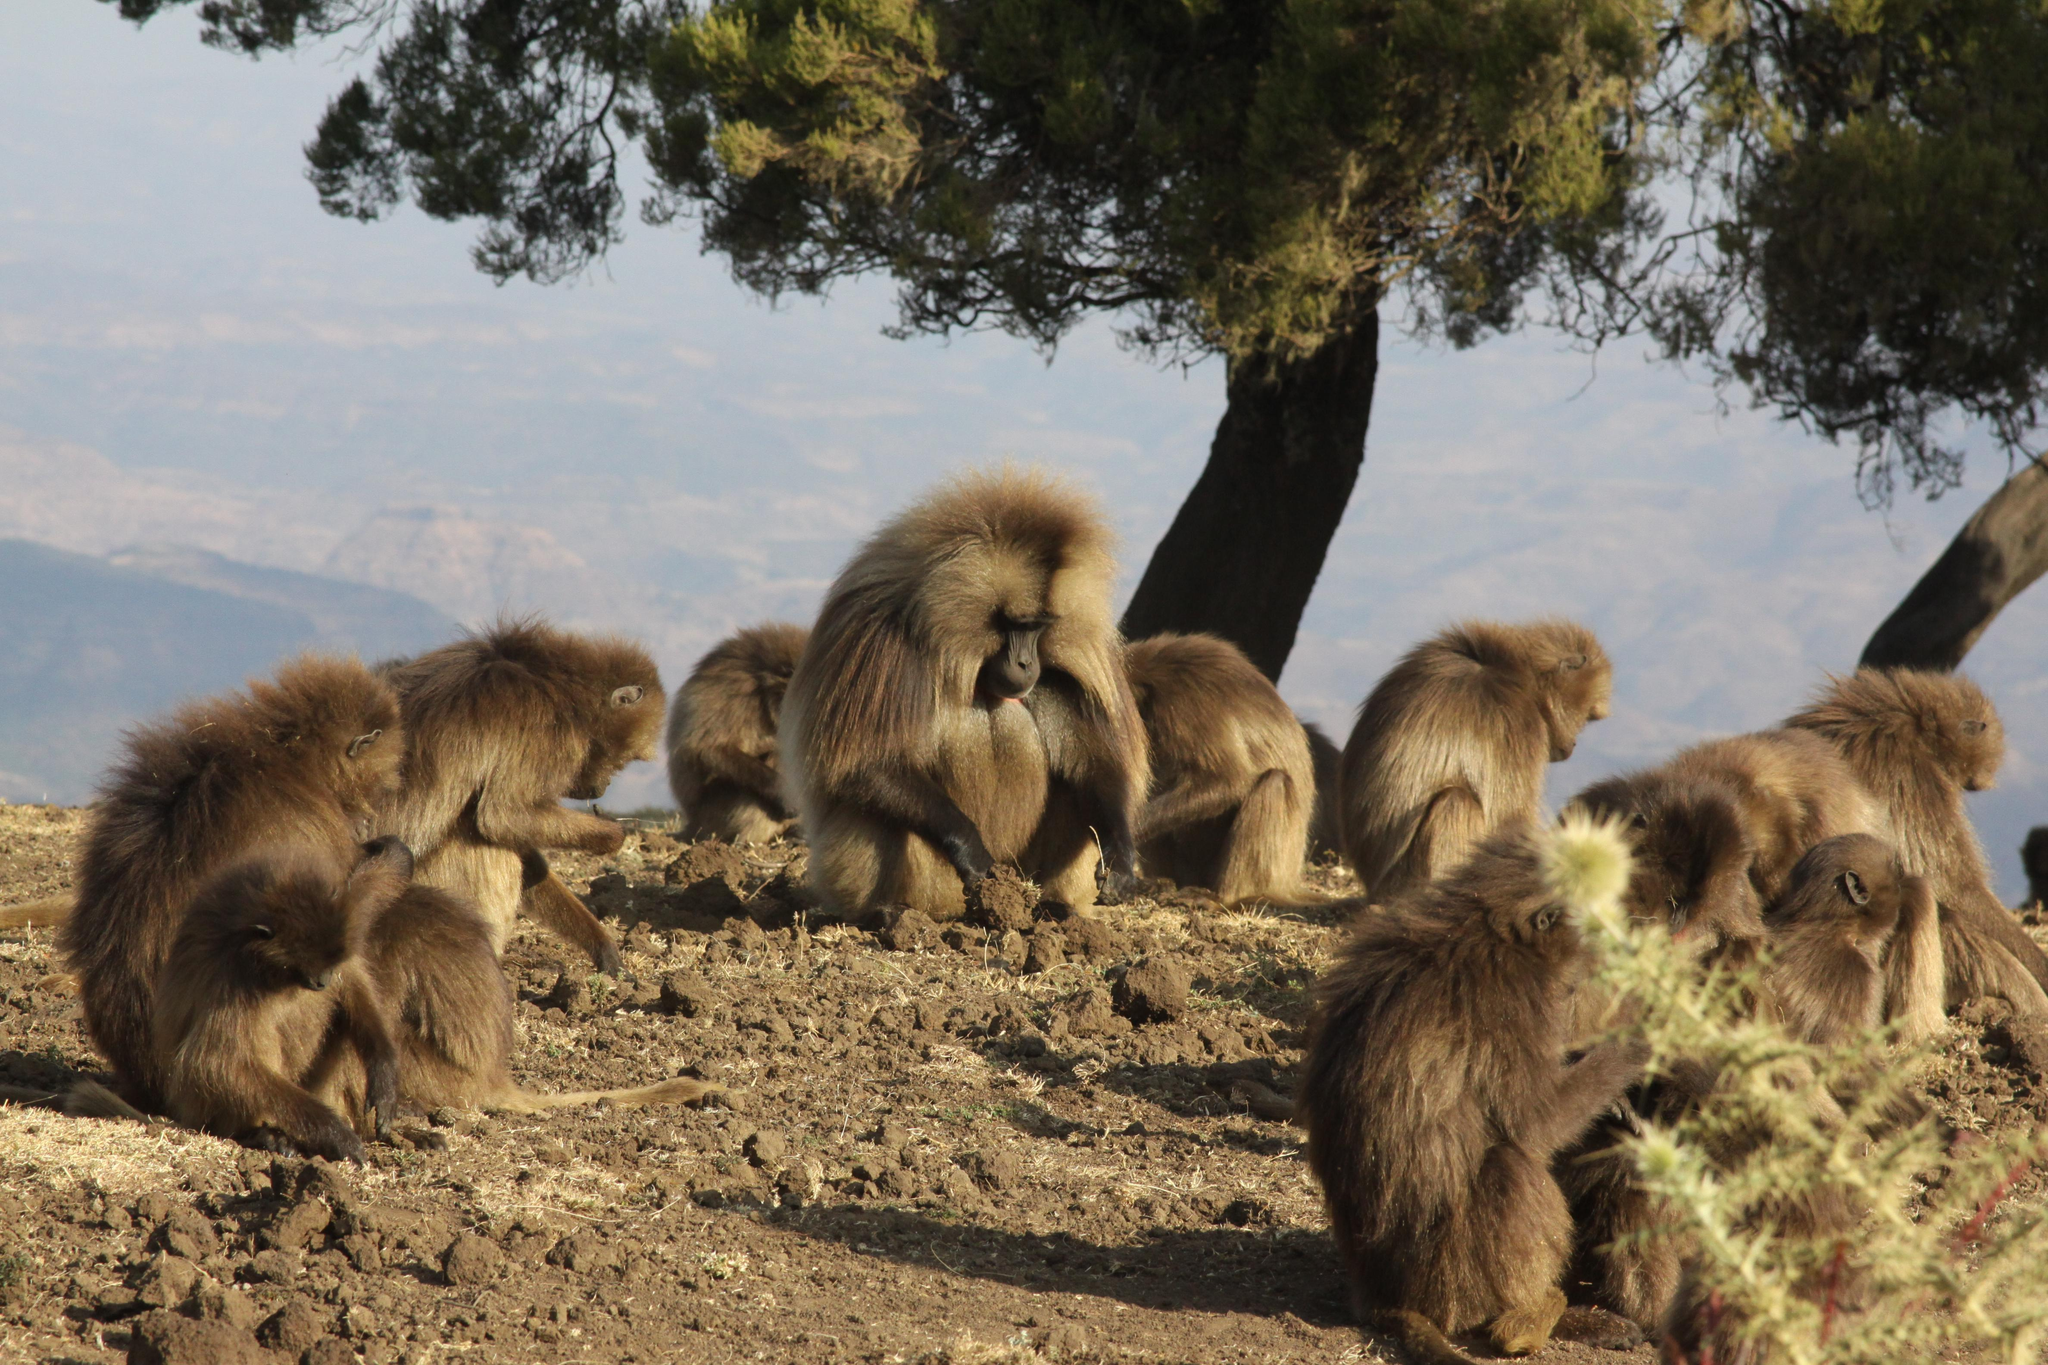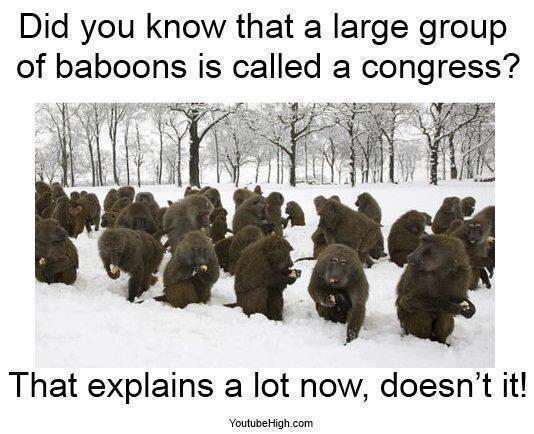The first image is the image on the left, the second image is the image on the right. Examine the images to the left and right. Is the description "There are monkeys sitting on grass." accurate? Answer yes or no. No. 